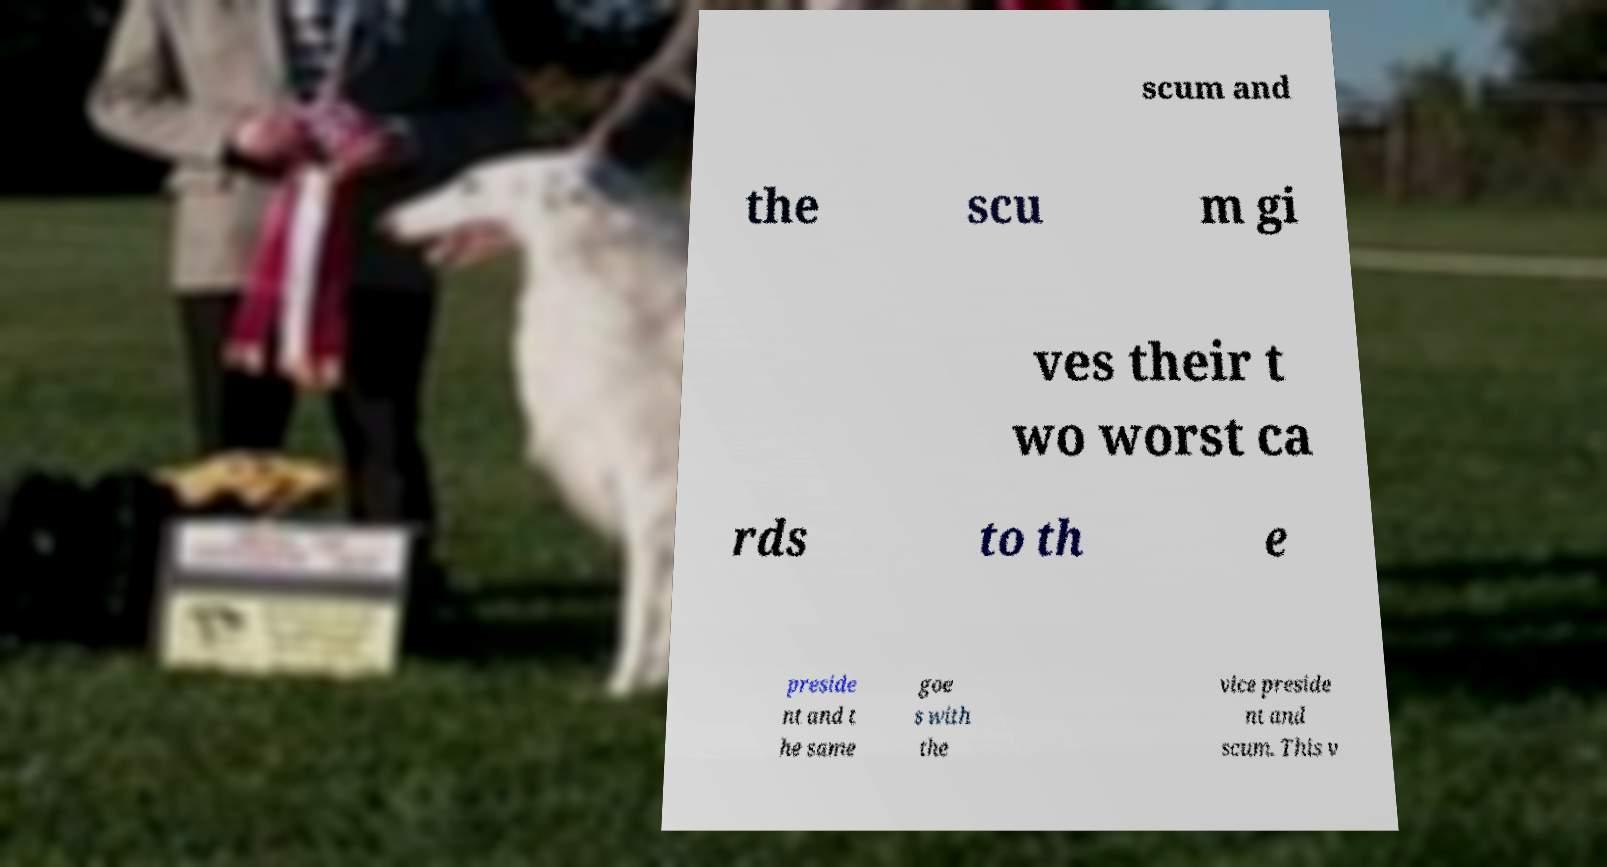Please read and relay the text visible in this image. What does it say? scum and the scu m gi ves their t wo worst ca rds to th e preside nt and t he same goe s with the vice preside nt and scum. This v 